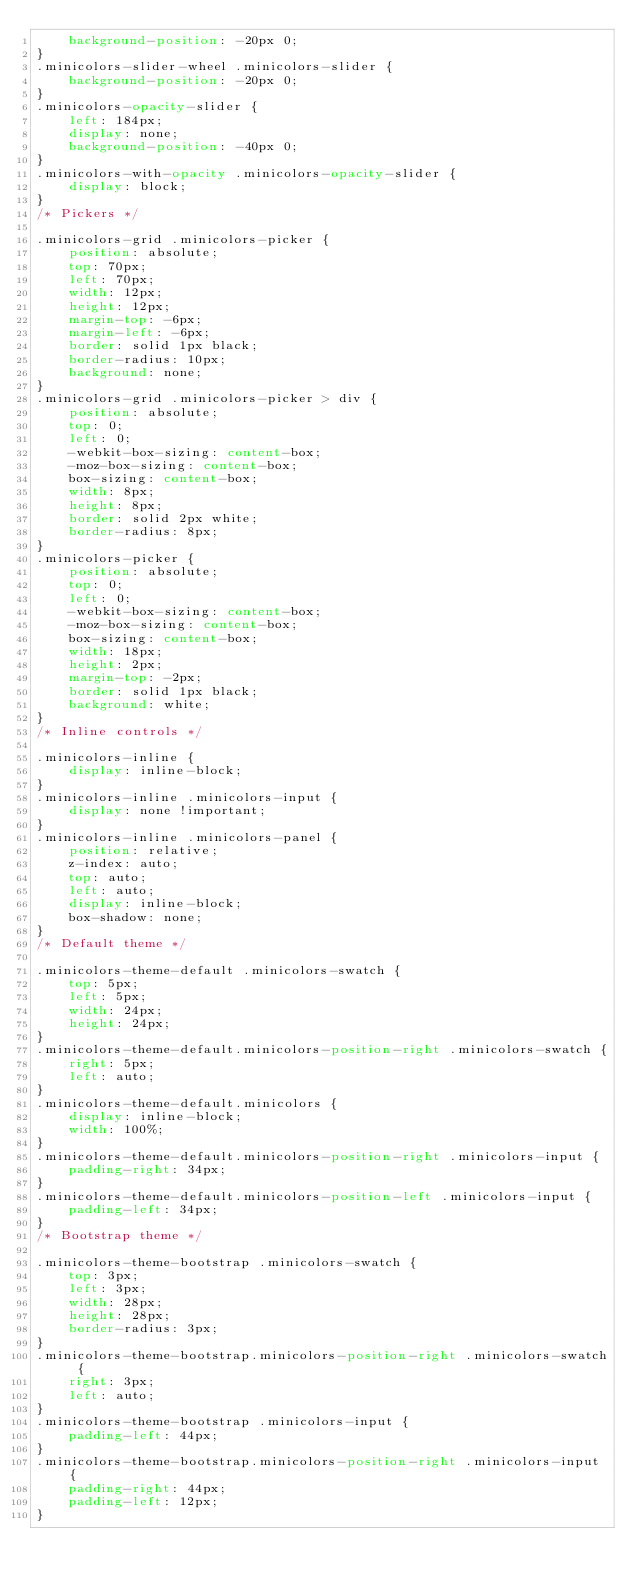Convert code to text. <code><loc_0><loc_0><loc_500><loc_500><_CSS_>    background-position: -20px 0;
}
.minicolors-slider-wheel .minicolors-slider {
    background-position: -20px 0;
}
.minicolors-opacity-slider {
    left: 184px;
    display: none;
    background-position: -40px 0;
}
.minicolors-with-opacity .minicolors-opacity-slider {
    display: block;
}
/* Pickers */

.minicolors-grid .minicolors-picker {
    position: absolute;
    top: 70px;
    left: 70px;
    width: 12px;
    height: 12px;
    margin-top: -6px;
    margin-left: -6px;
    border: solid 1px black;
    border-radius: 10px;
    background: none;
}
.minicolors-grid .minicolors-picker > div {
    position: absolute;
    top: 0;
    left: 0;
    -webkit-box-sizing: content-box;
    -moz-box-sizing: content-box;
    box-sizing: content-box;
    width: 8px;
    height: 8px;
    border: solid 2px white;
    border-radius: 8px;
}
.minicolors-picker {
    position: absolute;
    top: 0;
    left: 0;
    -webkit-box-sizing: content-box;
    -moz-box-sizing: content-box;
    box-sizing: content-box;
    width: 18px;
    height: 2px;
    margin-top: -2px;
    border: solid 1px black;
    background: white;
}
/* Inline controls */

.minicolors-inline {
    display: inline-block;
}
.minicolors-inline .minicolors-input {
    display: none !important;
}
.minicolors-inline .minicolors-panel {
    position: relative;
    z-index: auto;
    top: auto;
    left: auto;
    display: inline-block;
    box-shadow: none;
}
/* Default theme */

.minicolors-theme-default .minicolors-swatch {
    top: 5px;
    left: 5px;
    width: 24px;
    height: 24px;
}
.minicolors-theme-default.minicolors-position-right .minicolors-swatch {
    right: 5px;
    left: auto;
}
.minicolors-theme-default.minicolors {
    display: inline-block;
    width: 100%;
}
.minicolors-theme-default.minicolors-position-right .minicolors-input {
    padding-right: 34px;
}
.minicolors-theme-default.minicolors-position-left .minicolors-input {
    padding-left: 34px;
}
/* Bootstrap theme */

.minicolors-theme-bootstrap .minicolors-swatch {
    top: 3px;
    left: 3px;
    width: 28px;
    height: 28px;
    border-radius: 3px;
}
.minicolors-theme-bootstrap.minicolors-position-right .minicolors-swatch {
    right: 3px;
    left: auto;
}
.minicolors-theme-bootstrap .minicolors-input {
    padding-left: 44px;
}
.minicolors-theme-bootstrap.minicolors-position-right .minicolors-input {
    padding-right: 44px;
    padding-left: 12px;
}
</code> 